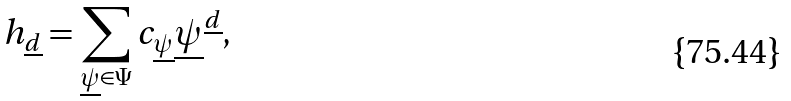Convert formula to latex. <formula><loc_0><loc_0><loc_500><loc_500>h _ { \underline { d } } = \sum _ { \underline { \psi } \in \Psi } c _ { \underline { \psi } } \underline { \psi } ^ { \underline { d } } ,</formula> 